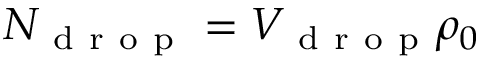<formula> <loc_0><loc_0><loc_500><loc_500>N _ { d r o p } = V _ { d r o p } \rho _ { 0 }</formula> 